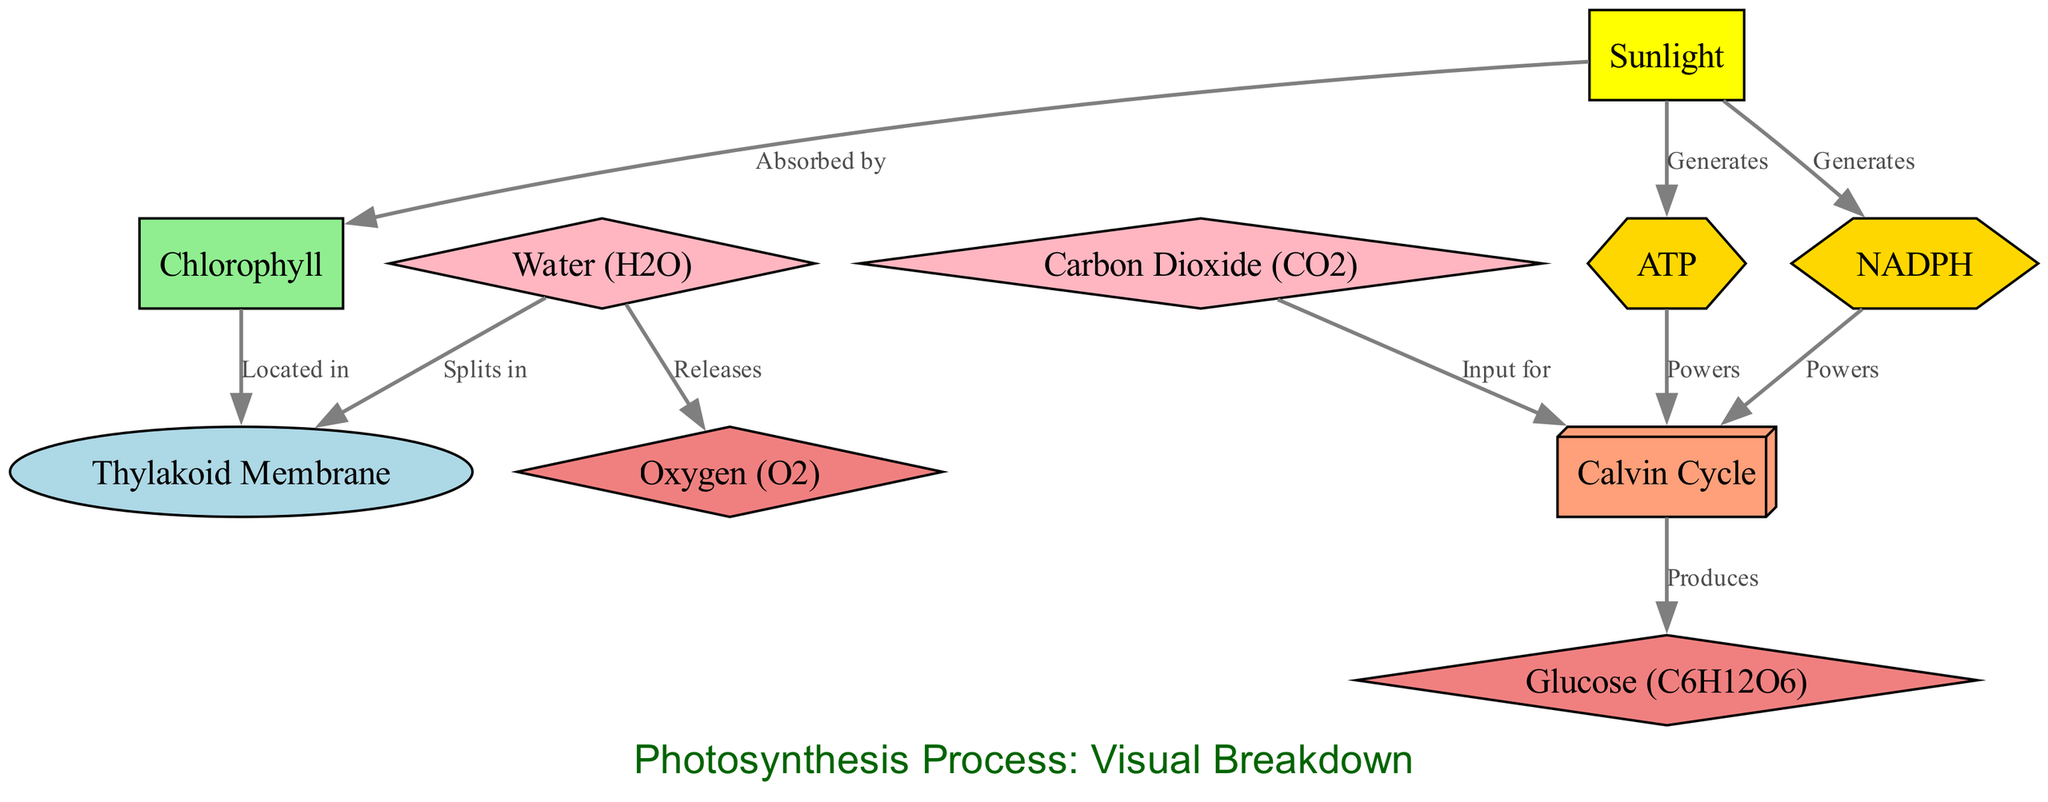What is the source of energy in the photosynthesis process? The diagram shows "Sunlight" as the energy source, indicated by the node labeled "Sunlight" that is categorized as a source type.
Answer: Sunlight Where is chlorophyll located? The node labeled "Chlorophyll" has an edge connecting it to the "Thylakoid Membrane" node, indicating that chlorophyll is found within this location.
Answer: Thylakoid Membrane How many products are generated from the photosynthesis process? The diagram identifies two products, "Oxygen" and "Glucose," which are represented as nodes categorized as product types. Counting these nodes confirms there are two products.
Answer: 2 Which reactant is split in the thylakoid membrane? According to the diagram, there is an edge labeled "Splits in" connecting "Water" to "Thylakoid Membrane," indicating that water is the reactant that is split in that location.
Answer: Water Which two energy compounds are generated from sunlight? The diagram shows edges labeled "Generates" from the "Sunlight" node leading to the nodes "ATP" and "NADPH," indicating that both ATP and NADPH are energy compounds generated from sunlight.
Answer: ATP and NADPH What powers the Calvin Cycle? The diagram displays edges from two energy nodes, "ATP" and "NADPH," leading to the "Calvin Cycle" node, indicating that both ATP and NADPH are required to power this process.
Answer: ATP and NADPH What is produced as a final product in the Calvin Cycle? The edge labeled "Produces" leads from the "Calvin Cycle" node to the "Glucose" node, indicating that glucose is the product formed at the end of this process.
Answer: Glucose Which reactant enters the Calvin Cycle? The diagram shows an edge labeled "Input for" connecting "Carbon Dioxide" to the "Calvin Cycle," meaning carbon dioxide is the reactant that enters this process.
Answer: Carbon Dioxide What is released during the splitting of water? There is an edge labeled "Releases" connecting the "Water" node to the "Oxygen" node, indicating that oxygen is released when water splits.
Answer: Oxygen 